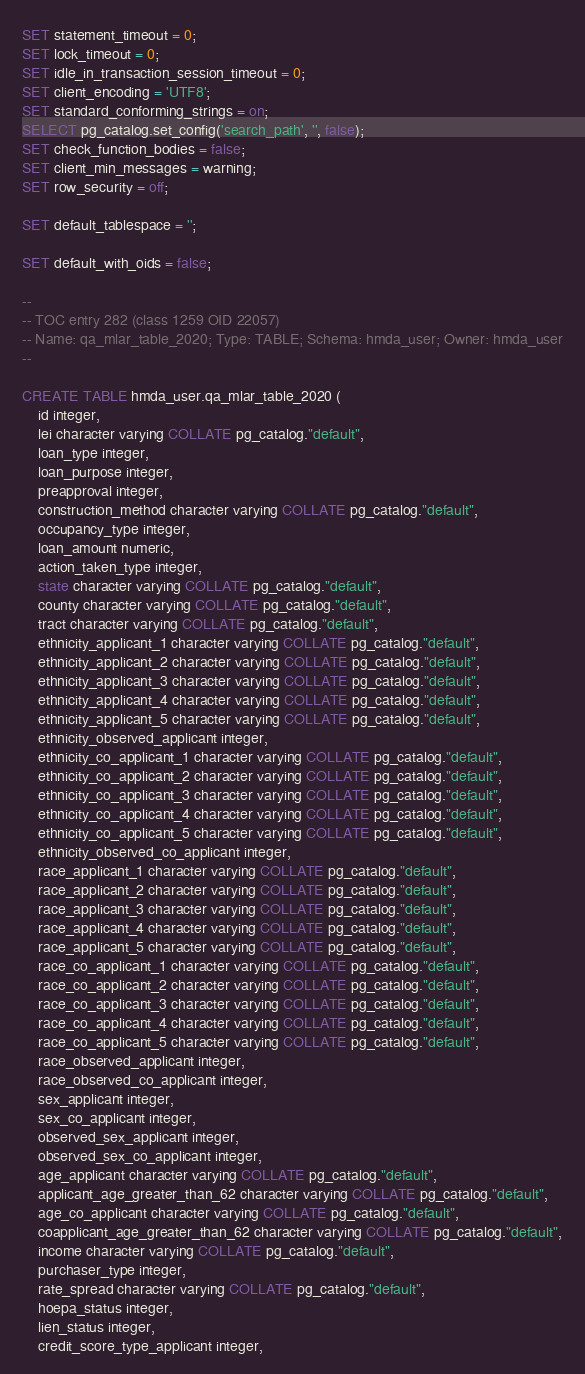<code> <loc_0><loc_0><loc_500><loc_500><_SQL_>

SET statement_timeout = 0;
SET lock_timeout = 0;
SET idle_in_transaction_session_timeout = 0;
SET client_encoding = 'UTF8';
SET standard_conforming_strings = on;
SELECT pg_catalog.set_config('search_path', '', false);
SET check_function_bodies = false;
SET client_min_messages = warning;
SET row_security = off;

SET default_tablespace = '';

SET default_with_oids = false;

--
-- TOC entry 282 (class 1259 OID 22057)
-- Name: qa_mlar_table_2020; Type: TABLE; Schema: hmda_user; Owner: hmda_user
--

CREATE TABLE hmda_user.qa_mlar_table_2020 (
    id integer,
    lei character varying COLLATE pg_catalog."default",
    loan_type integer,
    loan_purpose integer,
    preapproval integer,
    construction_method character varying COLLATE pg_catalog."default",
    occupancy_type integer,
    loan_amount numeric,
    action_taken_type integer,
    state character varying COLLATE pg_catalog."default",
    county character varying COLLATE pg_catalog."default",
    tract character varying COLLATE pg_catalog."default",
    ethnicity_applicant_1 character varying COLLATE pg_catalog."default",
    ethnicity_applicant_2 character varying COLLATE pg_catalog."default",
    ethnicity_applicant_3 character varying COLLATE pg_catalog."default",
    ethnicity_applicant_4 character varying COLLATE pg_catalog."default",
    ethnicity_applicant_5 character varying COLLATE pg_catalog."default",
    ethnicity_observed_applicant integer,
    ethnicity_co_applicant_1 character varying COLLATE pg_catalog."default",
    ethnicity_co_applicant_2 character varying COLLATE pg_catalog."default",
    ethnicity_co_applicant_3 character varying COLLATE pg_catalog."default",
    ethnicity_co_applicant_4 character varying COLLATE pg_catalog."default",
    ethnicity_co_applicant_5 character varying COLLATE pg_catalog."default",
    ethnicity_observed_co_applicant integer,
    race_applicant_1 character varying COLLATE pg_catalog."default",
    race_applicant_2 character varying COLLATE pg_catalog."default",
    race_applicant_3 character varying COLLATE pg_catalog."default",
    race_applicant_4 character varying COLLATE pg_catalog."default",
    race_applicant_5 character varying COLLATE pg_catalog."default",
    race_co_applicant_1 character varying COLLATE pg_catalog."default",
    race_co_applicant_2 character varying COLLATE pg_catalog."default",
    race_co_applicant_3 character varying COLLATE pg_catalog."default",
    race_co_applicant_4 character varying COLLATE pg_catalog."default",
    race_co_applicant_5 character varying COLLATE pg_catalog."default",
    race_observed_applicant integer,
    race_observed_co_applicant integer,
    sex_applicant integer,
    sex_co_applicant integer,
    observed_sex_applicant integer,
    observed_sex_co_applicant integer,
    age_applicant character varying COLLATE pg_catalog."default",
    applicant_age_greater_than_62 character varying COLLATE pg_catalog."default",
    age_co_applicant character varying COLLATE pg_catalog."default",
    coapplicant_age_greater_than_62 character varying COLLATE pg_catalog."default",
    income character varying COLLATE pg_catalog."default",
    purchaser_type integer,
    rate_spread character varying COLLATE pg_catalog."default",
    hoepa_status integer,
    lien_status integer,
    credit_score_type_applicant integer,</code> 